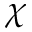<formula> <loc_0><loc_0><loc_500><loc_500>\chi</formula> 